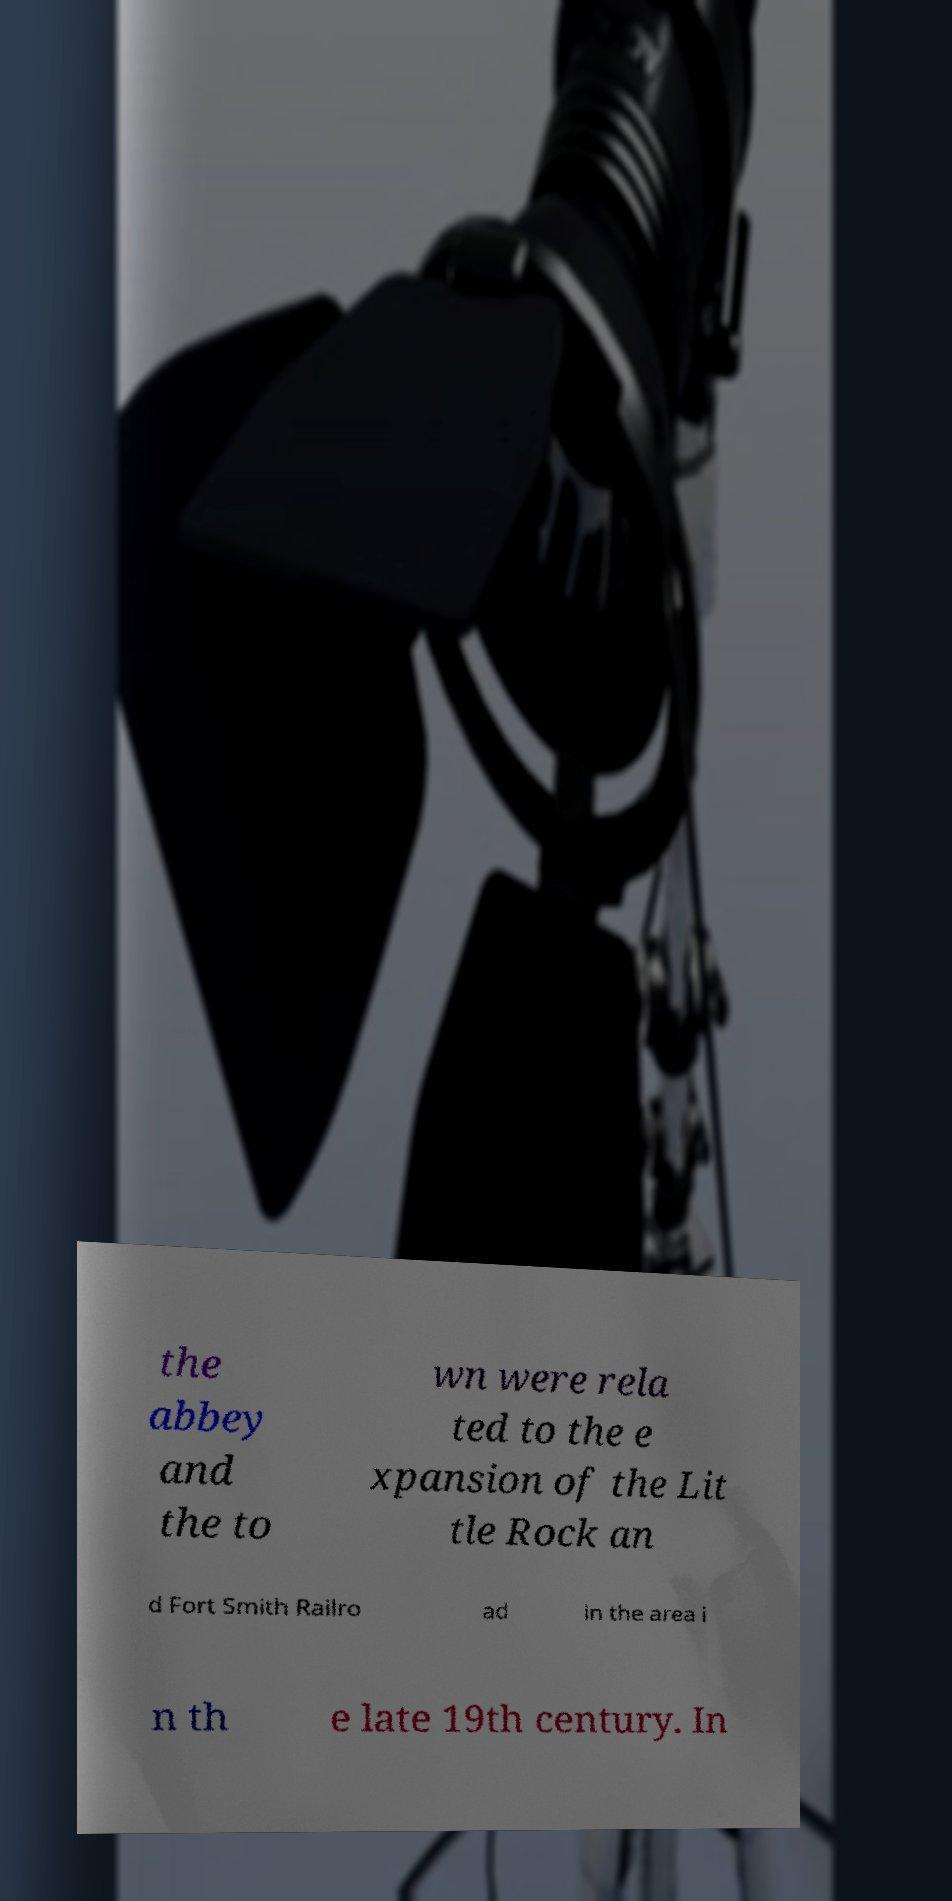Please read and relay the text visible in this image. What does it say? the abbey and the to wn were rela ted to the e xpansion of the Lit tle Rock an d Fort Smith Railro ad in the area i n th e late 19th century. In 